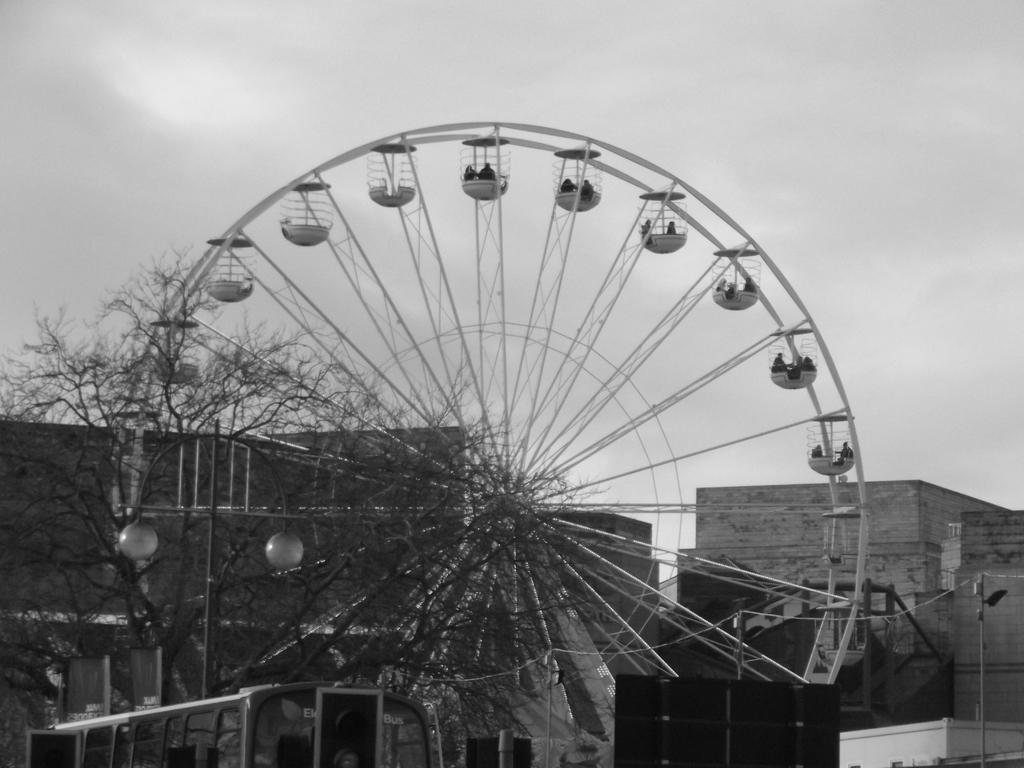Describe this image in one or two sentences. In this picture we can see a giant wheel, houses and some trees. 